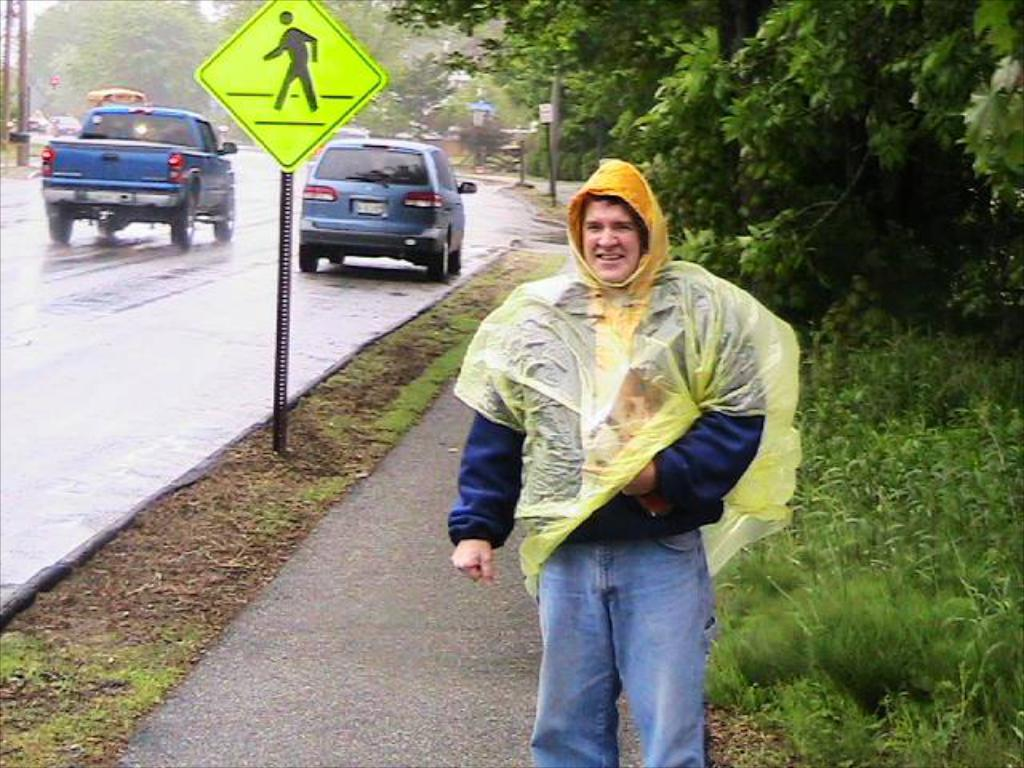What is the main subject in the image? There is a man standing in the image. What is located in the center of the image? There is a sign board in the center of the image. What can be seen on the road in the image? Vehicles are visible on the road in the image. What type of vegetation is in the background of the image? There are trees in the background of the image. What is present at the bottom of the image? There is grass at the bottom of the image. What type of bottle is being used as a prop on the stage in the image? There is no stage or bottle present in the image. 